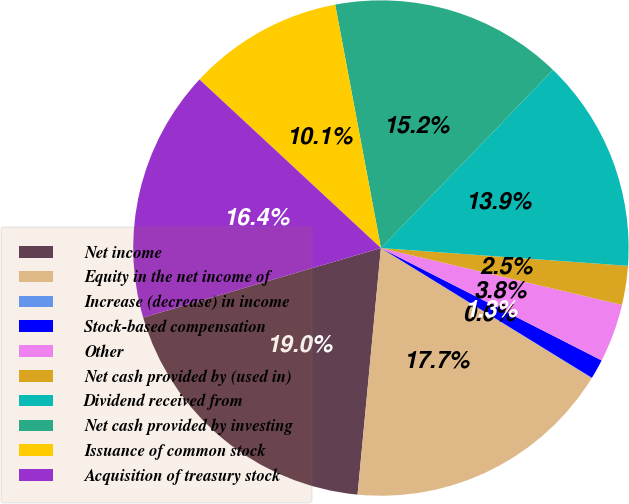Convert chart. <chart><loc_0><loc_0><loc_500><loc_500><pie_chart><fcel>Net income<fcel>Equity in the net income of<fcel>Increase (decrease) in income<fcel>Stock-based compensation<fcel>Other<fcel>Net cash provided by (used in)<fcel>Dividend received from<fcel>Net cash provided by investing<fcel>Issuance of common stock<fcel>Acquisition of treasury stock<nl><fcel>18.97%<fcel>17.71%<fcel>0.02%<fcel>1.28%<fcel>3.81%<fcel>2.54%<fcel>13.92%<fcel>15.18%<fcel>10.13%<fcel>16.44%<nl></chart> 